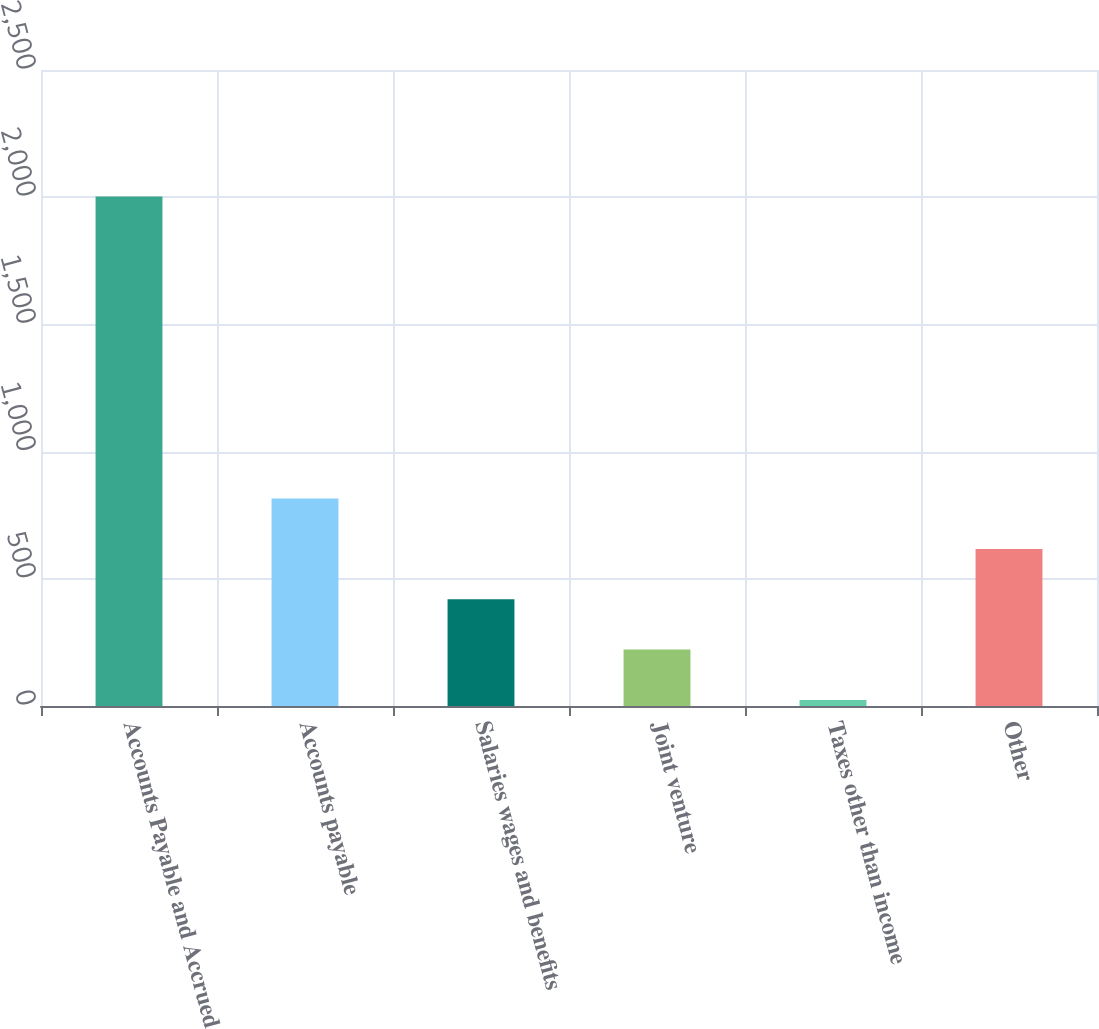<chart> <loc_0><loc_0><loc_500><loc_500><bar_chart><fcel>Accounts Payable and Accrued<fcel>Accounts payable<fcel>Salaries wages and benefits<fcel>Joint venture<fcel>Taxes other than income<fcel>Other<nl><fcel>2003<fcel>815.48<fcel>419.64<fcel>221.72<fcel>23.8<fcel>617.56<nl></chart> 